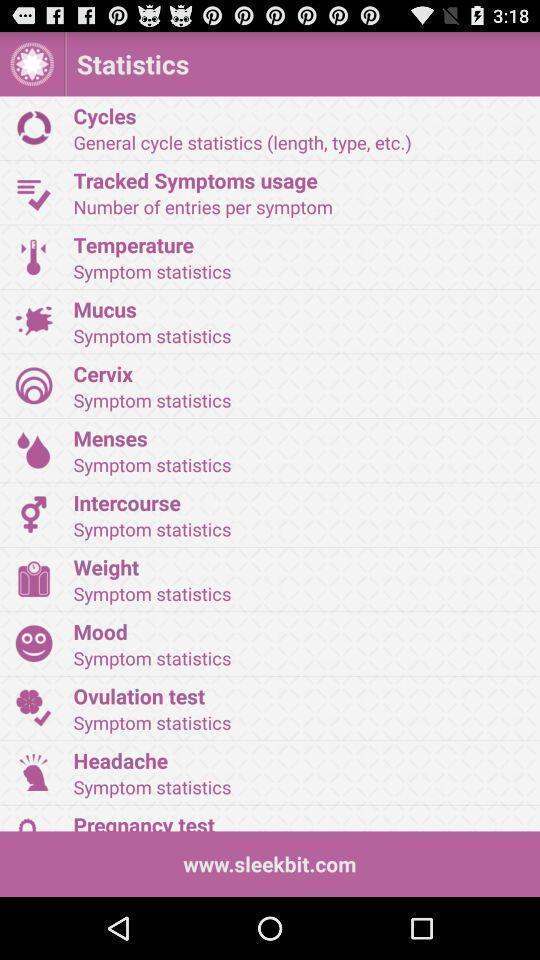Describe the content in this image. Page displays statistics in period tracker app. 